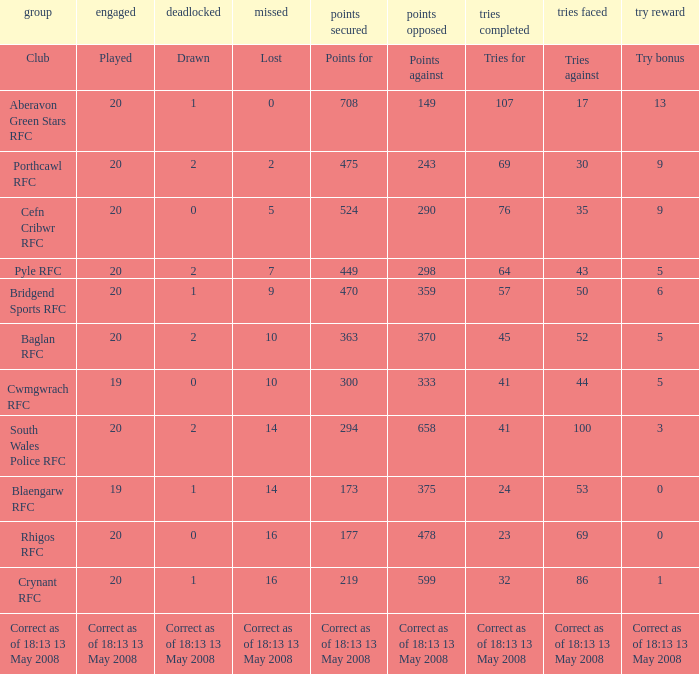What is the points when the try bonus is 1? 219.0. 